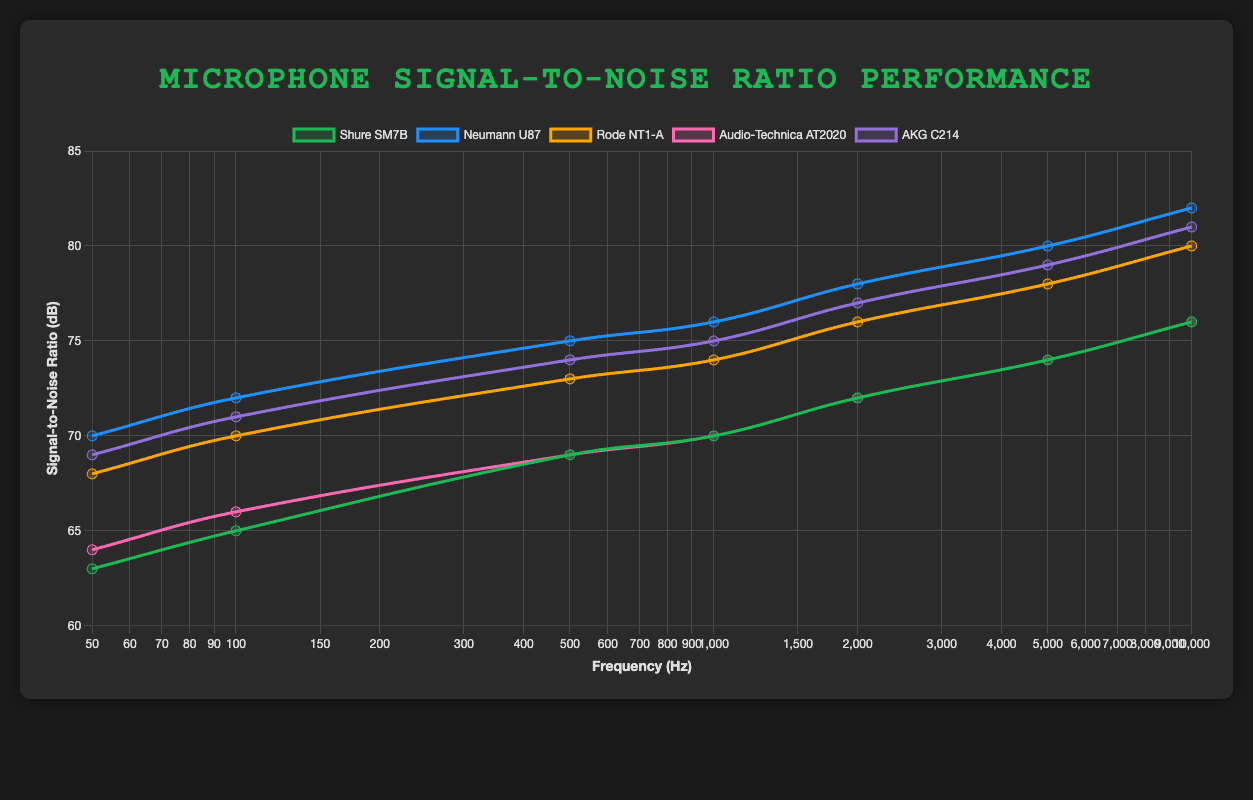What is the Signal-to-Noise Ratio (SNR) at 5000 Hz for the AKG C214 microphone? To find the SNR for the AKG C214 microphone at 5000 Hz, locate the line corresponding to the AKG C214 and then read the value where it intersects the 5000 Hz mark.
Answer: 79 dB Which microphone has the highest SNR at 100 Hz? Compare the SNR values at 100 Hz for all microphones. The Neumann U87 has an SNR of 72 dB, which is higher than the other microphones at this frequency.
Answer: Neumann U87 What is the difference in SNR between the Shure SM7B and the Rode NT1-A at 2000 Hz? Find the SNR values for both microphones at 2000 Hz and subtract the value of the Shure SM7B from the Rode NT1-A. Shure SM7B has 72 dB, and Rode NT1-A has 76 dB. The difference is 76 - 72 = 4 dB.
Answer: 4 dB Which microphone shows the least variation in SNR across the frequency range? Assess the range of SNR values (difference between maximum and minimum SNR) for each microphone. The Rode NT1-A ranges from 68 dB to 80 dB (a span of 12 dB), while the Shure SM7B ranges from 63 dB to 76 dB (a span of 13 dB). The Neumann U87 ranges from 70 dB to 82 dB (a span of 12 dB), the Audio-Technica AT2020 ranges from 64 dB to 76 dB (a span of 12 dB), and the AKG C214 ranges from 69 dB to 81 dB (a span of 12 dB). The gap is smallest for the Rode NT1-A.
Answer: Rode NT1-A How does the SNR at 1000 Hz for the Audio-Technica AT2020 compare to the SNR at the same frequency for the Neumann U87? Check the values at 1000 Hz for both microphones. The Audio-Technica AT2020 has an SNR of 70 dB, while the Neumann U87 has an SNR of 76 dB. The Neumann U87 has a higher SNR at 1000 Hz.
Answer: Neumann U87 is higher by 6 dB Which microphones have an SNR of at least 75 dB at 1000 Hz? Examine the SNR values at 1000 Hz for each microphone, and identify which ones are 75 dB or higher. Both the Neumann U87 and the AKG C214 meet this criterion with values of 76 dB and 75 dB, respectively.
Answer: Neumann U87 and AKG C214 At which frequency does the Shure SM7B microphone first reach an SNR of 70 dB or higher? Look at the SNR values for different frequencies for the Shure SM7B microphone, and identify the first frequency where the SNR is 70 dB or higher. This occurs at 1000 Hz with an SNR of 70 dB.
Answer: 1000 Hz What is the average SNR for the Rode NT1-A microphone across all the given frequencies? Sum up the SNR values for the Rode NT1-A across all frequencies (68 + 70 + 73 + 74 + 76 + 78 + 80) and divide by the number of frequencies (7). The total is (68+70+73+74+76+78+80) = 519, and the average is 519/7 ≈ 74.14 dB.
Answer: ~74.14 dB 